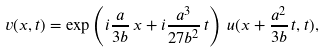Convert formula to latex. <formula><loc_0><loc_0><loc_500><loc_500>v ( x , t ) = \exp \left ( i \frac { a } { 3 b } \, x + i \frac { a ^ { 3 } } { 2 7 b ^ { 2 } } \, t \right ) \, u ( x + \frac { a ^ { 2 } } { 3 b } \, t , t ) ,</formula> 